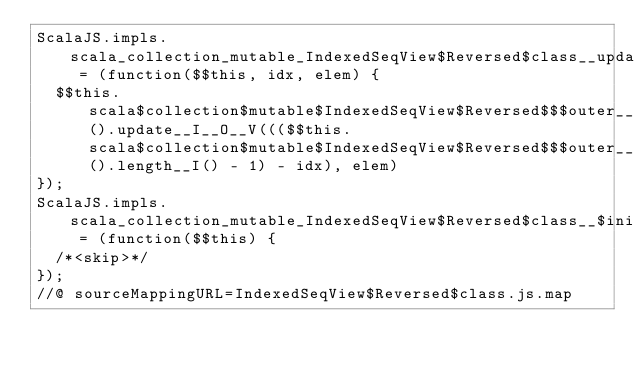<code> <loc_0><loc_0><loc_500><loc_500><_JavaScript_>ScalaJS.impls.scala_collection_mutable_IndexedSeqView$Reversed$class__update__Lscala_collection_mutable_IndexedSeqView$Reversed__I__O__V = (function($$this, idx, elem) {
  $$this.scala$collection$mutable$IndexedSeqView$Reversed$$$outer__Lscala_collection_mutable_IndexedSeqView().update__I__O__V((($$this.scala$collection$mutable$IndexedSeqView$Reversed$$$outer__Lscala_collection_mutable_IndexedSeqView().length__I() - 1) - idx), elem)
});
ScalaJS.impls.scala_collection_mutable_IndexedSeqView$Reversed$class__$init$__Lscala_collection_mutable_IndexedSeqView$Reversed__V = (function($$this) {
  /*<skip>*/
});
//@ sourceMappingURL=IndexedSeqView$Reversed$class.js.map
</code> 